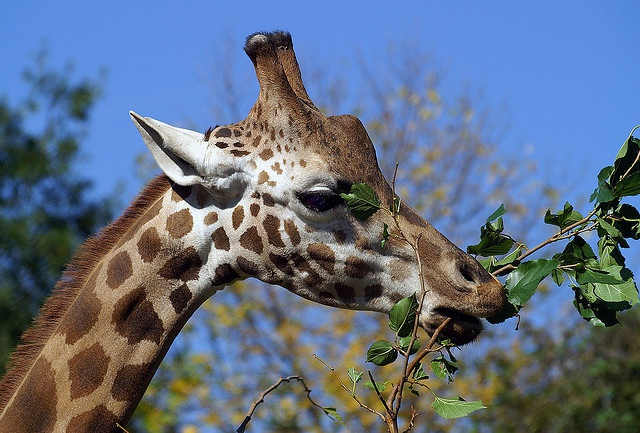Describe the objects in this image and their specific colors. I can see a giraffe in gray, black, and maroon tones in this image. 